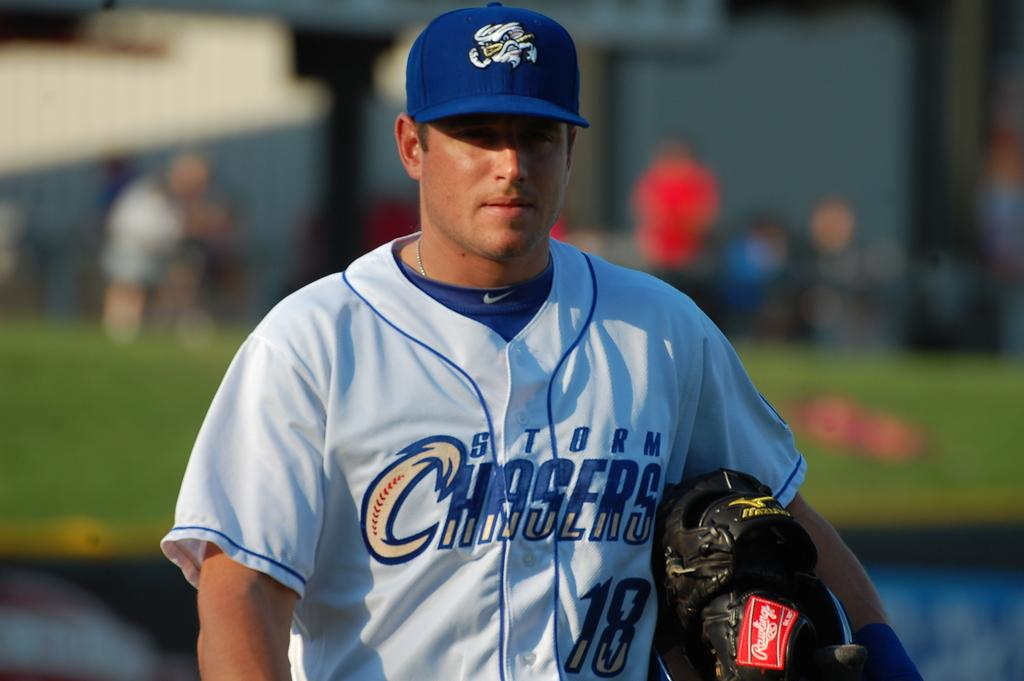Provide a one-sentence caption for the provided image. A baseball player wearing a jersey for the team Storm Chasers. 